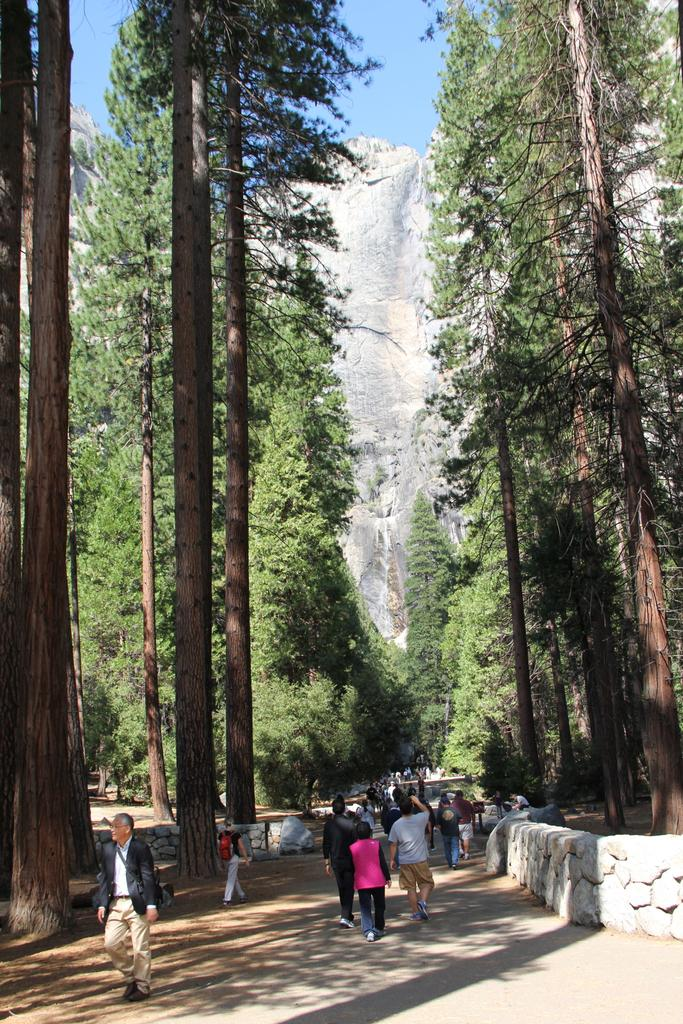What are the people in the image doing? The persons in the image are walking on the road. What type of natural elements can be seen in the image? There are trees visible in the image. What geographical feature is present in the image? There is a hill in the image. What is visible at the top of the image? The sky is visible at the top of the image. What type of surface can be seen on the right side of the image? There are stones on the right side of the image. How many pears are being carried by the persons in the image? There is no mention of pears in the image; the persons are walking on the road. What day of the week is it in the image? The day of the week is not mentioned in the image; it only shows persons walking on the road. 